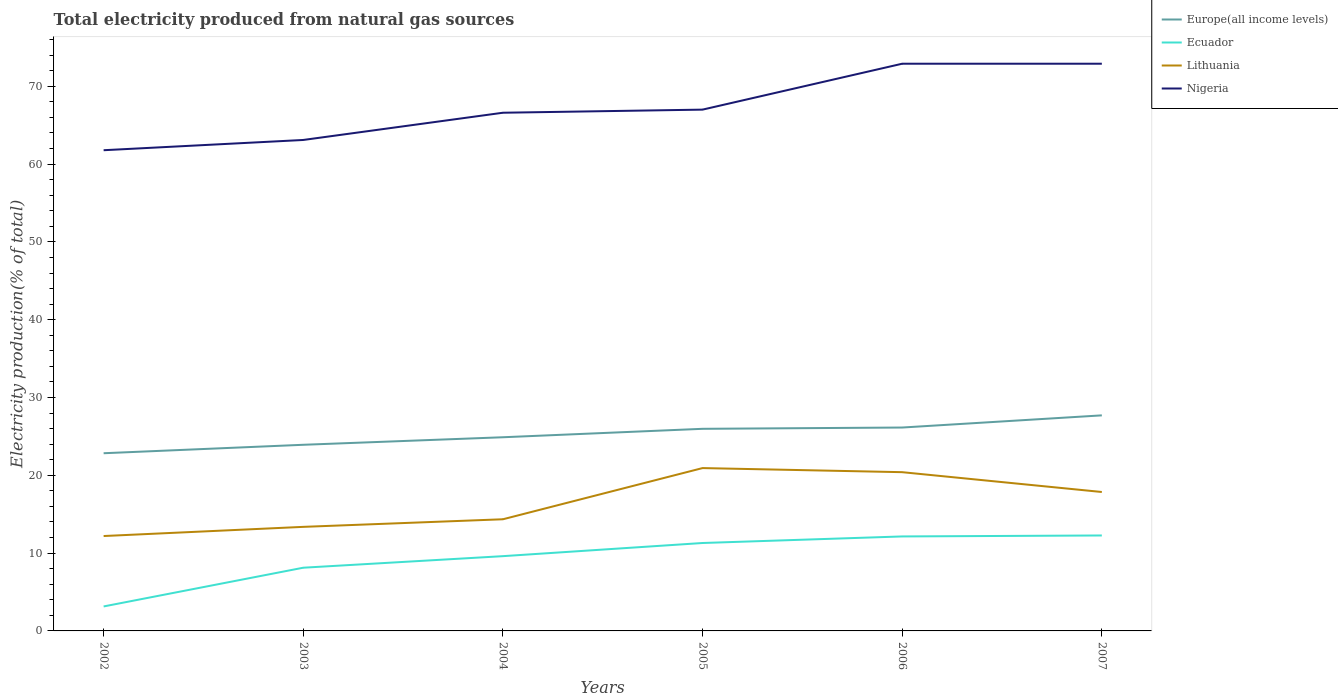How many different coloured lines are there?
Your response must be concise. 4. Does the line corresponding to Europe(all income levels) intersect with the line corresponding to Lithuania?
Your answer should be compact. No. Is the number of lines equal to the number of legend labels?
Provide a succinct answer. Yes. Across all years, what is the maximum total electricity produced in Lithuania?
Offer a very short reply. 12.19. What is the total total electricity produced in Europe(all income levels) in the graph?
Provide a short and direct response. -2.22. What is the difference between the highest and the second highest total electricity produced in Europe(all income levels)?
Provide a succinct answer. 4.87. Is the total electricity produced in Lithuania strictly greater than the total electricity produced in Ecuador over the years?
Ensure brevity in your answer.  No. How many lines are there?
Offer a terse response. 4. Does the graph contain any zero values?
Provide a short and direct response. No. Does the graph contain grids?
Give a very brief answer. No. Where does the legend appear in the graph?
Your response must be concise. Top right. How many legend labels are there?
Your response must be concise. 4. How are the legend labels stacked?
Offer a terse response. Vertical. What is the title of the graph?
Keep it short and to the point. Total electricity produced from natural gas sources. Does "Central Europe" appear as one of the legend labels in the graph?
Your answer should be compact. No. What is the Electricity production(% of total) of Europe(all income levels) in 2002?
Offer a very short reply. 22.84. What is the Electricity production(% of total) of Ecuador in 2002?
Ensure brevity in your answer.  3.15. What is the Electricity production(% of total) of Lithuania in 2002?
Provide a succinct answer. 12.19. What is the Electricity production(% of total) of Nigeria in 2002?
Your answer should be very brief. 61.78. What is the Electricity production(% of total) in Europe(all income levels) in 2003?
Your answer should be very brief. 23.92. What is the Electricity production(% of total) in Ecuador in 2003?
Offer a very short reply. 8.12. What is the Electricity production(% of total) of Lithuania in 2003?
Your answer should be very brief. 13.37. What is the Electricity production(% of total) in Nigeria in 2003?
Ensure brevity in your answer.  63.1. What is the Electricity production(% of total) of Europe(all income levels) in 2004?
Offer a very short reply. 24.89. What is the Electricity production(% of total) in Ecuador in 2004?
Make the answer very short. 9.61. What is the Electricity production(% of total) of Lithuania in 2004?
Your answer should be very brief. 14.35. What is the Electricity production(% of total) of Nigeria in 2004?
Your answer should be very brief. 66.6. What is the Electricity production(% of total) of Europe(all income levels) in 2005?
Your answer should be compact. 25.98. What is the Electricity production(% of total) of Ecuador in 2005?
Ensure brevity in your answer.  11.3. What is the Electricity production(% of total) of Lithuania in 2005?
Offer a terse response. 20.93. What is the Electricity production(% of total) in Nigeria in 2005?
Provide a succinct answer. 67. What is the Electricity production(% of total) of Europe(all income levels) in 2006?
Your answer should be very brief. 26.14. What is the Electricity production(% of total) in Ecuador in 2006?
Offer a very short reply. 12.14. What is the Electricity production(% of total) in Lithuania in 2006?
Keep it short and to the point. 20.4. What is the Electricity production(% of total) of Nigeria in 2006?
Provide a short and direct response. 72.9. What is the Electricity production(% of total) in Europe(all income levels) in 2007?
Your response must be concise. 27.71. What is the Electricity production(% of total) in Ecuador in 2007?
Your answer should be very brief. 12.27. What is the Electricity production(% of total) of Lithuania in 2007?
Offer a very short reply. 17.85. What is the Electricity production(% of total) in Nigeria in 2007?
Make the answer very short. 72.9. Across all years, what is the maximum Electricity production(% of total) of Europe(all income levels)?
Provide a short and direct response. 27.71. Across all years, what is the maximum Electricity production(% of total) in Ecuador?
Make the answer very short. 12.27. Across all years, what is the maximum Electricity production(% of total) of Lithuania?
Offer a very short reply. 20.93. Across all years, what is the maximum Electricity production(% of total) of Nigeria?
Offer a terse response. 72.9. Across all years, what is the minimum Electricity production(% of total) in Europe(all income levels)?
Ensure brevity in your answer.  22.84. Across all years, what is the minimum Electricity production(% of total) in Ecuador?
Keep it short and to the point. 3.15. Across all years, what is the minimum Electricity production(% of total) of Lithuania?
Provide a short and direct response. 12.19. Across all years, what is the minimum Electricity production(% of total) of Nigeria?
Offer a terse response. 61.78. What is the total Electricity production(% of total) of Europe(all income levels) in the graph?
Ensure brevity in your answer.  151.47. What is the total Electricity production(% of total) of Ecuador in the graph?
Offer a very short reply. 56.59. What is the total Electricity production(% of total) in Lithuania in the graph?
Offer a terse response. 99.11. What is the total Electricity production(% of total) in Nigeria in the graph?
Your answer should be compact. 404.28. What is the difference between the Electricity production(% of total) in Europe(all income levels) in 2002 and that in 2003?
Give a very brief answer. -1.09. What is the difference between the Electricity production(% of total) of Ecuador in 2002 and that in 2003?
Offer a terse response. -4.98. What is the difference between the Electricity production(% of total) in Lithuania in 2002 and that in 2003?
Give a very brief answer. -1.18. What is the difference between the Electricity production(% of total) in Nigeria in 2002 and that in 2003?
Offer a very short reply. -1.32. What is the difference between the Electricity production(% of total) in Europe(all income levels) in 2002 and that in 2004?
Your answer should be compact. -2.05. What is the difference between the Electricity production(% of total) of Ecuador in 2002 and that in 2004?
Ensure brevity in your answer.  -6.46. What is the difference between the Electricity production(% of total) of Lithuania in 2002 and that in 2004?
Offer a very short reply. -2.16. What is the difference between the Electricity production(% of total) of Nigeria in 2002 and that in 2004?
Offer a terse response. -4.82. What is the difference between the Electricity production(% of total) in Europe(all income levels) in 2002 and that in 2005?
Provide a succinct answer. -3.14. What is the difference between the Electricity production(% of total) in Ecuador in 2002 and that in 2005?
Give a very brief answer. -8.15. What is the difference between the Electricity production(% of total) in Lithuania in 2002 and that in 2005?
Your response must be concise. -8.73. What is the difference between the Electricity production(% of total) of Nigeria in 2002 and that in 2005?
Provide a short and direct response. -5.22. What is the difference between the Electricity production(% of total) of Europe(all income levels) in 2002 and that in 2006?
Your response must be concise. -3.3. What is the difference between the Electricity production(% of total) in Ecuador in 2002 and that in 2006?
Ensure brevity in your answer.  -9. What is the difference between the Electricity production(% of total) of Lithuania in 2002 and that in 2006?
Your answer should be very brief. -8.21. What is the difference between the Electricity production(% of total) in Nigeria in 2002 and that in 2006?
Offer a very short reply. -11.12. What is the difference between the Electricity production(% of total) of Europe(all income levels) in 2002 and that in 2007?
Your answer should be compact. -4.87. What is the difference between the Electricity production(% of total) in Ecuador in 2002 and that in 2007?
Your answer should be very brief. -9.12. What is the difference between the Electricity production(% of total) of Lithuania in 2002 and that in 2007?
Provide a succinct answer. -5.66. What is the difference between the Electricity production(% of total) of Nigeria in 2002 and that in 2007?
Your answer should be compact. -11.12. What is the difference between the Electricity production(% of total) of Europe(all income levels) in 2003 and that in 2004?
Ensure brevity in your answer.  -0.97. What is the difference between the Electricity production(% of total) in Ecuador in 2003 and that in 2004?
Give a very brief answer. -1.49. What is the difference between the Electricity production(% of total) of Lithuania in 2003 and that in 2004?
Keep it short and to the point. -0.98. What is the difference between the Electricity production(% of total) in Nigeria in 2003 and that in 2004?
Provide a succinct answer. -3.5. What is the difference between the Electricity production(% of total) of Europe(all income levels) in 2003 and that in 2005?
Your answer should be compact. -2.05. What is the difference between the Electricity production(% of total) of Ecuador in 2003 and that in 2005?
Your answer should be compact. -3.18. What is the difference between the Electricity production(% of total) of Lithuania in 2003 and that in 2005?
Ensure brevity in your answer.  -7.56. What is the difference between the Electricity production(% of total) of Europe(all income levels) in 2003 and that in 2006?
Keep it short and to the point. -2.22. What is the difference between the Electricity production(% of total) in Ecuador in 2003 and that in 2006?
Keep it short and to the point. -4.02. What is the difference between the Electricity production(% of total) in Lithuania in 2003 and that in 2006?
Provide a succinct answer. -7.03. What is the difference between the Electricity production(% of total) in Nigeria in 2003 and that in 2006?
Your answer should be very brief. -9.8. What is the difference between the Electricity production(% of total) of Europe(all income levels) in 2003 and that in 2007?
Offer a very short reply. -3.78. What is the difference between the Electricity production(% of total) in Ecuador in 2003 and that in 2007?
Provide a short and direct response. -4.14. What is the difference between the Electricity production(% of total) in Lithuania in 2003 and that in 2007?
Your answer should be very brief. -4.48. What is the difference between the Electricity production(% of total) in Nigeria in 2003 and that in 2007?
Your answer should be very brief. -9.8. What is the difference between the Electricity production(% of total) of Europe(all income levels) in 2004 and that in 2005?
Keep it short and to the point. -1.08. What is the difference between the Electricity production(% of total) of Ecuador in 2004 and that in 2005?
Offer a very short reply. -1.69. What is the difference between the Electricity production(% of total) in Lithuania in 2004 and that in 2005?
Make the answer very short. -6.58. What is the difference between the Electricity production(% of total) of Nigeria in 2004 and that in 2005?
Offer a very short reply. -0.4. What is the difference between the Electricity production(% of total) of Europe(all income levels) in 2004 and that in 2006?
Your response must be concise. -1.25. What is the difference between the Electricity production(% of total) in Ecuador in 2004 and that in 2006?
Offer a very short reply. -2.53. What is the difference between the Electricity production(% of total) of Lithuania in 2004 and that in 2006?
Offer a terse response. -6.05. What is the difference between the Electricity production(% of total) of Nigeria in 2004 and that in 2006?
Offer a very short reply. -6.3. What is the difference between the Electricity production(% of total) of Europe(all income levels) in 2004 and that in 2007?
Provide a short and direct response. -2.81. What is the difference between the Electricity production(% of total) in Ecuador in 2004 and that in 2007?
Offer a very short reply. -2.66. What is the difference between the Electricity production(% of total) in Lithuania in 2004 and that in 2007?
Give a very brief answer. -3.5. What is the difference between the Electricity production(% of total) of Nigeria in 2004 and that in 2007?
Offer a terse response. -6.3. What is the difference between the Electricity production(% of total) in Europe(all income levels) in 2005 and that in 2006?
Your answer should be very brief. -0.16. What is the difference between the Electricity production(% of total) of Ecuador in 2005 and that in 2006?
Offer a very short reply. -0.84. What is the difference between the Electricity production(% of total) of Lithuania in 2005 and that in 2006?
Make the answer very short. 0.53. What is the difference between the Electricity production(% of total) in Nigeria in 2005 and that in 2006?
Make the answer very short. -5.9. What is the difference between the Electricity production(% of total) of Europe(all income levels) in 2005 and that in 2007?
Offer a very short reply. -1.73. What is the difference between the Electricity production(% of total) in Ecuador in 2005 and that in 2007?
Offer a terse response. -0.97. What is the difference between the Electricity production(% of total) of Lithuania in 2005 and that in 2007?
Your answer should be very brief. 3.08. What is the difference between the Electricity production(% of total) in Nigeria in 2005 and that in 2007?
Offer a terse response. -5.9. What is the difference between the Electricity production(% of total) in Europe(all income levels) in 2006 and that in 2007?
Your answer should be compact. -1.57. What is the difference between the Electricity production(% of total) in Ecuador in 2006 and that in 2007?
Your answer should be very brief. -0.12. What is the difference between the Electricity production(% of total) in Lithuania in 2006 and that in 2007?
Keep it short and to the point. 2.55. What is the difference between the Electricity production(% of total) in Nigeria in 2006 and that in 2007?
Your answer should be very brief. -0. What is the difference between the Electricity production(% of total) in Europe(all income levels) in 2002 and the Electricity production(% of total) in Ecuador in 2003?
Make the answer very short. 14.71. What is the difference between the Electricity production(% of total) of Europe(all income levels) in 2002 and the Electricity production(% of total) of Lithuania in 2003?
Ensure brevity in your answer.  9.46. What is the difference between the Electricity production(% of total) in Europe(all income levels) in 2002 and the Electricity production(% of total) in Nigeria in 2003?
Give a very brief answer. -40.26. What is the difference between the Electricity production(% of total) in Ecuador in 2002 and the Electricity production(% of total) in Lithuania in 2003?
Make the answer very short. -10.23. What is the difference between the Electricity production(% of total) in Ecuador in 2002 and the Electricity production(% of total) in Nigeria in 2003?
Provide a short and direct response. -59.95. What is the difference between the Electricity production(% of total) of Lithuania in 2002 and the Electricity production(% of total) of Nigeria in 2003?
Offer a very short reply. -50.9. What is the difference between the Electricity production(% of total) in Europe(all income levels) in 2002 and the Electricity production(% of total) in Ecuador in 2004?
Offer a terse response. 13.23. What is the difference between the Electricity production(% of total) in Europe(all income levels) in 2002 and the Electricity production(% of total) in Lithuania in 2004?
Give a very brief answer. 8.49. What is the difference between the Electricity production(% of total) of Europe(all income levels) in 2002 and the Electricity production(% of total) of Nigeria in 2004?
Offer a terse response. -43.76. What is the difference between the Electricity production(% of total) in Ecuador in 2002 and the Electricity production(% of total) in Lithuania in 2004?
Your response must be concise. -11.2. What is the difference between the Electricity production(% of total) of Ecuador in 2002 and the Electricity production(% of total) of Nigeria in 2004?
Your response must be concise. -63.45. What is the difference between the Electricity production(% of total) of Lithuania in 2002 and the Electricity production(% of total) of Nigeria in 2004?
Your answer should be compact. -54.4. What is the difference between the Electricity production(% of total) of Europe(all income levels) in 2002 and the Electricity production(% of total) of Ecuador in 2005?
Provide a succinct answer. 11.54. What is the difference between the Electricity production(% of total) of Europe(all income levels) in 2002 and the Electricity production(% of total) of Lithuania in 2005?
Offer a terse response. 1.91. What is the difference between the Electricity production(% of total) of Europe(all income levels) in 2002 and the Electricity production(% of total) of Nigeria in 2005?
Your answer should be compact. -44.16. What is the difference between the Electricity production(% of total) in Ecuador in 2002 and the Electricity production(% of total) in Lithuania in 2005?
Offer a terse response. -17.78. What is the difference between the Electricity production(% of total) of Ecuador in 2002 and the Electricity production(% of total) of Nigeria in 2005?
Make the answer very short. -63.85. What is the difference between the Electricity production(% of total) in Lithuania in 2002 and the Electricity production(% of total) in Nigeria in 2005?
Your answer should be very brief. -54.8. What is the difference between the Electricity production(% of total) in Europe(all income levels) in 2002 and the Electricity production(% of total) in Ecuador in 2006?
Provide a short and direct response. 10.69. What is the difference between the Electricity production(% of total) in Europe(all income levels) in 2002 and the Electricity production(% of total) in Lithuania in 2006?
Your answer should be compact. 2.43. What is the difference between the Electricity production(% of total) of Europe(all income levels) in 2002 and the Electricity production(% of total) of Nigeria in 2006?
Give a very brief answer. -50.06. What is the difference between the Electricity production(% of total) of Ecuador in 2002 and the Electricity production(% of total) of Lithuania in 2006?
Provide a succinct answer. -17.26. What is the difference between the Electricity production(% of total) of Ecuador in 2002 and the Electricity production(% of total) of Nigeria in 2006?
Provide a succinct answer. -69.75. What is the difference between the Electricity production(% of total) of Lithuania in 2002 and the Electricity production(% of total) of Nigeria in 2006?
Give a very brief answer. -60.7. What is the difference between the Electricity production(% of total) in Europe(all income levels) in 2002 and the Electricity production(% of total) in Ecuador in 2007?
Offer a very short reply. 10.57. What is the difference between the Electricity production(% of total) in Europe(all income levels) in 2002 and the Electricity production(% of total) in Lithuania in 2007?
Provide a short and direct response. 4.98. What is the difference between the Electricity production(% of total) in Europe(all income levels) in 2002 and the Electricity production(% of total) in Nigeria in 2007?
Your answer should be very brief. -50.06. What is the difference between the Electricity production(% of total) in Ecuador in 2002 and the Electricity production(% of total) in Lithuania in 2007?
Ensure brevity in your answer.  -14.71. What is the difference between the Electricity production(% of total) of Ecuador in 2002 and the Electricity production(% of total) of Nigeria in 2007?
Provide a succinct answer. -69.75. What is the difference between the Electricity production(% of total) of Lithuania in 2002 and the Electricity production(% of total) of Nigeria in 2007?
Your response must be concise. -60.71. What is the difference between the Electricity production(% of total) in Europe(all income levels) in 2003 and the Electricity production(% of total) in Ecuador in 2004?
Your response must be concise. 14.32. What is the difference between the Electricity production(% of total) of Europe(all income levels) in 2003 and the Electricity production(% of total) of Lithuania in 2004?
Offer a terse response. 9.57. What is the difference between the Electricity production(% of total) in Europe(all income levels) in 2003 and the Electricity production(% of total) in Nigeria in 2004?
Offer a very short reply. -42.67. What is the difference between the Electricity production(% of total) of Ecuador in 2003 and the Electricity production(% of total) of Lithuania in 2004?
Your answer should be compact. -6.23. What is the difference between the Electricity production(% of total) of Ecuador in 2003 and the Electricity production(% of total) of Nigeria in 2004?
Your answer should be very brief. -58.48. What is the difference between the Electricity production(% of total) of Lithuania in 2003 and the Electricity production(% of total) of Nigeria in 2004?
Your answer should be compact. -53.23. What is the difference between the Electricity production(% of total) of Europe(all income levels) in 2003 and the Electricity production(% of total) of Ecuador in 2005?
Offer a terse response. 12.62. What is the difference between the Electricity production(% of total) in Europe(all income levels) in 2003 and the Electricity production(% of total) in Lithuania in 2005?
Your answer should be very brief. 2.99. What is the difference between the Electricity production(% of total) in Europe(all income levels) in 2003 and the Electricity production(% of total) in Nigeria in 2005?
Ensure brevity in your answer.  -43.08. What is the difference between the Electricity production(% of total) of Ecuador in 2003 and the Electricity production(% of total) of Lithuania in 2005?
Provide a succinct answer. -12.81. What is the difference between the Electricity production(% of total) in Ecuador in 2003 and the Electricity production(% of total) in Nigeria in 2005?
Your answer should be very brief. -58.88. What is the difference between the Electricity production(% of total) in Lithuania in 2003 and the Electricity production(% of total) in Nigeria in 2005?
Make the answer very short. -53.63. What is the difference between the Electricity production(% of total) in Europe(all income levels) in 2003 and the Electricity production(% of total) in Ecuador in 2006?
Your answer should be very brief. 11.78. What is the difference between the Electricity production(% of total) in Europe(all income levels) in 2003 and the Electricity production(% of total) in Lithuania in 2006?
Offer a terse response. 3.52. What is the difference between the Electricity production(% of total) in Europe(all income levels) in 2003 and the Electricity production(% of total) in Nigeria in 2006?
Your answer should be compact. -48.97. What is the difference between the Electricity production(% of total) of Ecuador in 2003 and the Electricity production(% of total) of Lithuania in 2006?
Offer a very short reply. -12.28. What is the difference between the Electricity production(% of total) in Ecuador in 2003 and the Electricity production(% of total) in Nigeria in 2006?
Provide a succinct answer. -64.78. What is the difference between the Electricity production(% of total) in Lithuania in 2003 and the Electricity production(% of total) in Nigeria in 2006?
Your response must be concise. -59.53. What is the difference between the Electricity production(% of total) in Europe(all income levels) in 2003 and the Electricity production(% of total) in Ecuador in 2007?
Offer a very short reply. 11.66. What is the difference between the Electricity production(% of total) in Europe(all income levels) in 2003 and the Electricity production(% of total) in Lithuania in 2007?
Provide a short and direct response. 6.07. What is the difference between the Electricity production(% of total) of Europe(all income levels) in 2003 and the Electricity production(% of total) of Nigeria in 2007?
Offer a very short reply. -48.98. What is the difference between the Electricity production(% of total) of Ecuador in 2003 and the Electricity production(% of total) of Lithuania in 2007?
Offer a very short reply. -9.73. What is the difference between the Electricity production(% of total) of Ecuador in 2003 and the Electricity production(% of total) of Nigeria in 2007?
Ensure brevity in your answer.  -64.78. What is the difference between the Electricity production(% of total) in Lithuania in 2003 and the Electricity production(% of total) in Nigeria in 2007?
Your response must be concise. -59.53. What is the difference between the Electricity production(% of total) of Europe(all income levels) in 2004 and the Electricity production(% of total) of Ecuador in 2005?
Offer a terse response. 13.59. What is the difference between the Electricity production(% of total) of Europe(all income levels) in 2004 and the Electricity production(% of total) of Lithuania in 2005?
Keep it short and to the point. 3.96. What is the difference between the Electricity production(% of total) in Europe(all income levels) in 2004 and the Electricity production(% of total) in Nigeria in 2005?
Provide a succinct answer. -42.11. What is the difference between the Electricity production(% of total) of Ecuador in 2004 and the Electricity production(% of total) of Lithuania in 2005?
Your response must be concise. -11.32. What is the difference between the Electricity production(% of total) of Ecuador in 2004 and the Electricity production(% of total) of Nigeria in 2005?
Give a very brief answer. -57.39. What is the difference between the Electricity production(% of total) of Lithuania in 2004 and the Electricity production(% of total) of Nigeria in 2005?
Your response must be concise. -52.65. What is the difference between the Electricity production(% of total) of Europe(all income levels) in 2004 and the Electricity production(% of total) of Ecuador in 2006?
Make the answer very short. 12.75. What is the difference between the Electricity production(% of total) in Europe(all income levels) in 2004 and the Electricity production(% of total) in Lithuania in 2006?
Your answer should be compact. 4.49. What is the difference between the Electricity production(% of total) in Europe(all income levels) in 2004 and the Electricity production(% of total) in Nigeria in 2006?
Your response must be concise. -48.01. What is the difference between the Electricity production(% of total) of Ecuador in 2004 and the Electricity production(% of total) of Lithuania in 2006?
Your answer should be compact. -10.79. What is the difference between the Electricity production(% of total) in Ecuador in 2004 and the Electricity production(% of total) in Nigeria in 2006?
Offer a very short reply. -63.29. What is the difference between the Electricity production(% of total) in Lithuania in 2004 and the Electricity production(% of total) in Nigeria in 2006?
Offer a terse response. -58.55. What is the difference between the Electricity production(% of total) in Europe(all income levels) in 2004 and the Electricity production(% of total) in Ecuador in 2007?
Your answer should be very brief. 12.62. What is the difference between the Electricity production(% of total) in Europe(all income levels) in 2004 and the Electricity production(% of total) in Lithuania in 2007?
Your answer should be very brief. 7.04. What is the difference between the Electricity production(% of total) of Europe(all income levels) in 2004 and the Electricity production(% of total) of Nigeria in 2007?
Keep it short and to the point. -48.01. What is the difference between the Electricity production(% of total) of Ecuador in 2004 and the Electricity production(% of total) of Lithuania in 2007?
Provide a short and direct response. -8.25. What is the difference between the Electricity production(% of total) of Ecuador in 2004 and the Electricity production(% of total) of Nigeria in 2007?
Keep it short and to the point. -63.29. What is the difference between the Electricity production(% of total) of Lithuania in 2004 and the Electricity production(% of total) of Nigeria in 2007?
Offer a very short reply. -58.55. What is the difference between the Electricity production(% of total) of Europe(all income levels) in 2005 and the Electricity production(% of total) of Ecuador in 2006?
Your answer should be compact. 13.83. What is the difference between the Electricity production(% of total) of Europe(all income levels) in 2005 and the Electricity production(% of total) of Lithuania in 2006?
Offer a very short reply. 5.57. What is the difference between the Electricity production(% of total) of Europe(all income levels) in 2005 and the Electricity production(% of total) of Nigeria in 2006?
Keep it short and to the point. -46.92. What is the difference between the Electricity production(% of total) of Ecuador in 2005 and the Electricity production(% of total) of Lithuania in 2006?
Give a very brief answer. -9.1. What is the difference between the Electricity production(% of total) of Ecuador in 2005 and the Electricity production(% of total) of Nigeria in 2006?
Ensure brevity in your answer.  -61.6. What is the difference between the Electricity production(% of total) in Lithuania in 2005 and the Electricity production(% of total) in Nigeria in 2006?
Provide a short and direct response. -51.97. What is the difference between the Electricity production(% of total) of Europe(all income levels) in 2005 and the Electricity production(% of total) of Ecuador in 2007?
Give a very brief answer. 13.71. What is the difference between the Electricity production(% of total) of Europe(all income levels) in 2005 and the Electricity production(% of total) of Lithuania in 2007?
Ensure brevity in your answer.  8.12. What is the difference between the Electricity production(% of total) in Europe(all income levels) in 2005 and the Electricity production(% of total) in Nigeria in 2007?
Provide a short and direct response. -46.92. What is the difference between the Electricity production(% of total) of Ecuador in 2005 and the Electricity production(% of total) of Lithuania in 2007?
Provide a succinct answer. -6.55. What is the difference between the Electricity production(% of total) of Ecuador in 2005 and the Electricity production(% of total) of Nigeria in 2007?
Your response must be concise. -61.6. What is the difference between the Electricity production(% of total) of Lithuania in 2005 and the Electricity production(% of total) of Nigeria in 2007?
Provide a short and direct response. -51.97. What is the difference between the Electricity production(% of total) in Europe(all income levels) in 2006 and the Electricity production(% of total) in Ecuador in 2007?
Offer a terse response. 13.87. What is the difference between the Electricity production(% of total) in Europe(all income levels) in 2006 and the Electricity production(% of total) in Lithuania in 2007?
Provide a short and direct response. 8.29. What is the difference between the Electricity production(% of total) of Europe(all income levels) in 2006 and the Electricity production(% of total) of Nigeria in 2007?
Ensure brevity in your answer.  -46.76. What is the difference between the Electricity production(% of total) in Ecuador in 2006 and the Electricity production(% of total) in Lithuania in 2007?
Your response must be concise. -5.71. What is the difference between the Electricity production(% of total) of Ecuador in 2006 and the Electricity production(% of total) of Nigeria in 2007?
Your answer should be very brief. -60.76. What is the difference between the Electricity production(% of total) in Lithuania in 2006 and the Electricity production(% of total) in Nigeria in 2007?
Your answer should be very brief. -52.5. What is the average Electricity production(% of total) of Europe(all income levels) per year?
Give a very brief answer. 25.25. What is the average Electricity production(% of total) in Ecuador per year?
Ensure brevity in your answer.  9.43. What is the average Electricity production(% of total) in Lithuania per year?
Ensure brevity in your answer.  16.52. What is the average Electricity production(% of total) in Nigeria per year?
Provide a short and direct response. 67.38. In the year 2002, what is the difference between the Electricity production(% of total) of Europe(all income levels) and Electricity production(% of total) of Ecuador?
Your response must be concise. 19.69. In the year 2002, what is the difference between the Electricity production(% of total) in Europe(all income levels) and Electricity production(% of total) in Lithuania?
Your response must be concise. 10.64. In the year 2002, what is the difference between the Electricity production(% of total) of Europe(all income levels) and Electricity production(% of total) of Nigeria?
Provide a succinct answer. -38.95. In the year 2002, what is the difference between the Electricity production(% of total) in Ecuador and Electricity production(% of total) in Lithuania?
Your answer should be very brief. -9.05. In the year 2002, what is the difference between the Electricity production(% of total) of Ecuador and Electricity production(% of total) of Nigeria?
Your answer should be compact. -58.64. In the year 2002, what is the difference between the Electricity production(% of total) of Lithuania and Electricity production(% of total) of Nigeria?
Provide a short and direct response. -49.59. In the year 2003, what is the difference between the Electricity production(% of total) in Europe(all income levels) and Electricity production(% of total) in Ecuador?
Provide a short and direct response. 15.8. In the year 2003, what is the difference between the Electricity production(% of total) of Europe(all income levels) and Electricity production(% of total) of Lithuania?
Offer a terse response. 10.55. In the year 2003, what is the difference between the Electricity production(% of total) in Europe(all income levels) and Electricity production(% of total) in Nigeria?
Ensure brevity in your answer.  -39.18. In the year 2003, what is the difference between the Electricity production(% of total) in Ecuador and Electricity production(% of total) in Lithuania?
Provide a short and direct response. -5.25. In the year 2003, what is the difference between the Electricity production(% of total) of Ecuador and Electricity production(% of total) of Nigeria?
Give a very brief answer. -54.98. In the year 2003, what is the difference between the Electricity production(% of total) of Lithuania and Electricity production(% of total) of Nigeria?
Provide a short and direct response. -49.73. In the year 2004, what is the difference between the Electricity production(% of total) of Europe(all income levels) and Electricity production(% of total) of Ecuador?
Provide a short and direct response. 15.28. In the year 2004, what is the difference between the Electricity production(% of total) of Europe(all income levels) and Electricity production(% of total) of Lithuania?
Offer a terse response. 10.54. In the year 2004, what is the difference between the Electricity production(% of total) in Europe(all income levels) and Electricity production(% of total) in Nigeria?
Your response must be concise. -41.71. In the year 2004, what is the difference between the Electricity production(% of total) of Ecuador and Electricity production(% of total) of Lithuania?
Offer a very short reply. -4.74. In the year 2004, what is the difference between the Electricity production(% of total) of Ecuador and Electricity production(% of total) of Nigeria?
Ensure brevity in your answer.  -56.99. In the year 2004, what is the difference between the Electricity production(% of total) of Lithuania and Electricity production(% of total) of Nigeria?
Offer a very short reply. -52.25. In the year 2005, what is the difference between the Electricity production(% of total) in Europe(all income levels) and Electricity production(% of total) in Ecuador?
Offer a very short reply. 14.68. In the year 2005, what is the difference between the Electricity production(% of total) in Europe(all income levels) and Electricity production(% of total) in Lithuania?
Make the answer very short. 5.05. In the year 2005, what is the difference between the Electricity production(% of total) of Europe(all income levels) and Electricity production(% of total) of Nigeria?
Ensure brevity in your answer.  -41.02. In the year 2005, what is the difference between the Electricity production(% of total) of Ecuador and Electricity production(% of total) of Lithuania?
Make the answer very short. -9.63. In the year 2005, what is the difference between the Electricity production(% of total) of Ecuador and Electricity production(% of total) of Nigeria?
Give a very brief answer. -55.7. In the year 2005, what is the difference between the Electricity production(% of total) of Lithuania and Electricity production(% of total) of Nigeria?
Your answer should be very brief. -46.07. In the year 2006, what is the difference between the Electricity production(% of total) in Europe(all income levels) and Electricity production(% of total) in Ecuador?
Offer a terse response. 14. In the year 2006, what is the difference between the Electricity production(% of total) in Europe(all income levels) and Electricity production(% of total) in Lithuania?
Your answer should be compact. 5.74. In the year 2006, what is the difference between the Electricity production(% of total) in Europe(all income levels) and Electricity production(% of total) in Nigeria?
Make the answer very short. -46.76. In the year 2006, what is the difference between the Electricity production(% of total) in Ecuador and Electricity production(% of total) in Lithuania?
Offer a very short reply. -8.26. In the year 2006, what is the difference between the Electricity production(% of total) of Ecuador and Electricity production(% of total) of Nigeria?
Provide a short and direct response. -60.76. In the year 2006, what is the difference between the Electricity production(% of total) in Lithuania and Electricity production(% of total) in Nigeria?
Make the answer very short. -52.5. In the year 2007, what is the difference between the Electricity production(% of total) in Europe(all income levels) and Electricity production(% of total) in Ecuador?
Provide a short and direct response. 15.44. In the year 2007, what is the difference between the Electricity production(% of total) in Europe(all income levels) and Electricity production(% of total) in Lithuania?
Ensure brevity in your answer.  9.85. In the year 2007, what is the difference between the Electricity production(% of total) in Europe(all income levels) and Electricity production(% of total) in Nigeria?
Ensure brevity in your answer.  -45.19. In the year 2007, what is the difference between the Electricity production(% of total) in Ecuador and Electricity production(% of total) in Lithuania?
Provide a succinct answer. -5.59. In the year 2007, what is the difference between the Electricity production(% of total) of Ecuador and Electricity production(% of total) of Nigeria?
Your answer should be compact. -60.63. In the year 2007, what is the difference between the Electricity production(% of total) of Lithuania and Electricity production(% of total) of Nigeria?
Offer a very short reply. -55.05. What is the ratio of the Electricity production(% of total) of Europe(all income levels) in 2002 to that in 2003?
Your answer should be very brief. 0.95. What is the ratio of the Electricity production(% of total) of Ecuador in 2002 to that in 2003?
Give a very brief answer. 0.39. What is the ratio of the Electricity production(% of total) of Lithuania in 2002 to that in 2003?
Keep it short and to the point. 0.91. What is the ratio of the Electricity production(% of total) in Nigeria in 2002 to that in 2003?
Your response must be concise. 0.98. What is the ratio of the Electricity production(% of total) of Europe(all income levels) in 2002 to that in 2004?
Give a very brief answer. 0.92. What is the ratio of the Electricity production(% of total) of Ecuador in 2002 to that in 2004?
Provide a short and direct response. 0.33. What is the ratio of the Electricity production(% of total) of Lithuania in 2002 to that in 2004?
Your response must be concise. 0.85. What is the ratio of the Electricity production(% of total) of Nigeria in 2002 to that in 2004?
Provide a short and direct response. 0.93. What is the ratio of the Electricity production(% of total) of Europe(all income levels) in 2002 to that in 2005?
Ensure brevity in your answer.  0.88. What is the ratio of the Electricity production(% of total) of Ecuador in 2002 to that in 2005?
Ensure brevity in your answer.  0.28. What is the ratio of the Electricity production(% of total) in Lithuania in 2002 to that in 2005?
Offer a terse response. 0.58. What is the ratio of the Electricity production(% of total) of Nigeria in 2002 to that in 2005?
Offer a terse response. 0.92. What is the ratio of the Electricity production(% of total) in Europe(all income levels) in 2002 to that in 2006?
Keep it short and to the point. 0.87. What is the ratio of the Electricity production(% of total) of Ecuador in 2002 to that in 2006?
Give a very brief answer. 0.26. What is the ratio of the Electricity production(% of total) in Lithuania in 2002 to that in 2006?
Keep it short and to the point. 0.6. What is the ratio of the Electricity production(% of total) in Nigeria in 2002 to that in 2006?
Make the answer very short. 0.85. What is the ratio of the Electricity production(% of total) in Europe(all income levels) in 2002 to that in 2007?
Your answer should be compact. 0.82. What is the ratio of the Electricity production(% of total) of Ecuador in 2002 to that in 2007?
Your answer should be compact. 0.26. What is the ratio of the Electricity production(% of total) of Lithuania in 2002 to that in 2007?
Provide a short and direct response. 0.68. What is the ratio of the Electricity production(% of total) in Nigeria in 2002 to that in 2007?
Make the answer very short. 0.85. What is the ratio of the Electricity production(% of total) of Europe(all income levels) in 2003 to that in 2004?
Offer a terse response. 0.96. What is the ratio of the Electricity production(% of total) of Ecuador in 2003 to that in 2004?
Ensure brevity in your answer.  0.85. What is the ratio of the Electricity production(% of total) in Lithuania in 2003 to that in 2004?
Your answer should be very brief. 0.93. What is the ratio of the Electricity production(% of total) in Nigeria in 2003 to that in 2004?
Your response must be concise. 0.95. What is the ratio of the Electricity production(% of total) of Europe(all income levels) in 2003 to that in 2005?
Offer a terse response. 0.92. What is the ratio of the Electricity production(% of total) of Ecuador in 2003 to that in 2005?
Offer a very short reply. 0.72. What is the ratio of the Electricity production(% of total) in Lithuania in 2003 to that in 2005?
Your answer should be compact. 0.64. What is the ratio of the Electricity production(% of total) of Nigeria in 2003 to that in 2005?
Your answer should be very brief. 0.94. What is the ratio of the Electricity production(% of total) of Europe(all income levels) in 2003 to that in 2006?
Make the answer very short. 0.92. What is the ratio of the Electricity production(% of total) in Ecuador in 2003 to that in 2006?
Your answer should be compact. 0.67. What is the ratio of the Electricity production(% of total) of Lithuania in 2003 to that in 2006?
Your response must be concise. 0.66. What is the ratio of the Electricity production(% of total) in Nigeria in 2003 to that in 2006?
Your answer should be very brief. 0.87. What is the ratio of the Electricity production(% of total) in Europe(all income levels) in 2003 to that in 2007?
Provide a succinct answer. 0.86. What is the ratio of the Electricity production(% of total) of Ecuador in 2003 to that in 2007?
Give a very brief answer. 0.66. What is the ratio of the Electricity production(% of total) in Lithuania in 2003 to that in 2007?
Your answer should be very brief. 0.75. What is the ratio of the Electricity production(% of total) in Nigeria in 2003 to that in 2007?
Provide a succinct answer. 0.87. What is the ratio of the Electricity production(% of total) of Ecuador in 2004 to that in 2005?
Provide a short and direct response. 0.85. What is the ratio of the Electricity production(% of total) in Lithuania in 2004 to that in 2005?
Your response must be concise. 0.69. What is the ratio of the Electricity production(% of total) in Nigeria in 2004 to that in 2005?
Provide a short and direct response. 0.99. What is the ratio of the Electricity production(% of total) in Europe(all income levels) in 2004 to that in 2006?
Offer a terse response. 0.95. What is the ratio of the Electricity production(% of total) in Ecuador in 2004 to that in 2006?
Your response must be concise. 0.79. What is the ratio of the Electricity production(% of total) in Lithuania in 2004 to that in 2006?
Provide a short and direct response. 0.7. What is the ratio of the Electricity production(% of total) of Nigeria in 2004 to that in 2006?
Make the answer very short. 0.91. What is the ratio of the Electricity production(% of total) of Europe(all income levels) in 2004 to that in 2007?
Your answer should be compact. 0.9. What is the ratio of the Electricity production(% of total) in Ecuador in 2004 to that in 2007?
Provide a short and direct response. 0.78. What is the ratio of the Electricity production(% of total) in Lithuania in 2004 to that in 2007?
Your answer should be very brief. 0.8. What is the ratio of the Electricity production(% of total) in Nigeria in 2004 to that in 2007?
Provide a succinct answer. 0.91. What is the ratio of the Electricity production(% of total) in Ecuador in 2005 to that in 2006?
Make the answer very short. 0.93. What is the ratio of the Electricity production(% of total) of Lithuania in 2005 to that in 2006?
Your answer should be compact. 1.03. What is the ratio of the Electricity production(% of total) in Nigeria in 2005 to that in 2006?
Keep it short and to the point. 0.92. What is the ratio of the Electricity production(% of total) of Europe(all income levels) in 2005 to that in 2007?
Ensure brevity in your answer.  0.94. What is the ratio of the Electricity production(% of total) in Ecuador in 2005 to that in 2007?
Your response must be concise. 0.92. What is the ratio of the Electricity production(% of total) of Lithuania in 2005 to that in 2007?
Make the answer very short. 1.17. What is the ratio of the Electricity production(% of total) of Nigeria in 2005 to that in 2007?
Give a very brief answer. 0.92. What is the ratio of the Electricity production(% of total) of Europe(all income levels) in 2006 to that in 2007?
Provide a short and direct response. 0.94. What is the ratio of the Electricity production(% of total) in Lithuania in 2006 to that in 2007?
Offer a terse response. 1.14. What is the difference between the highest and the second highest Electricity production(% of total) in Europe(all income levels)?
Ensure brevity in your answer.  1.57. What is the difference between the highest and the second highest Electricity production(% of total) of Ecuador?
Give a very brief answer. 0.12. What is the difference between the highest and the second highest Electricity production(% of total) in Lithuania?
Offer a terse response. 0.53. What is the difference between the highest and the lowest Electricity production(% of total) in Europe(all income levels)?
Make the answer very short. 4.87. What is the difference between the highest and the lowest Electricity production(% of total) of Ecuador?
Offer a very short reply. 9.12. What is the difference between the highest and the lowest Electricity production(% of total) in Lithuania?
Provide a succinct answer. 8.73. What is the difference between the highest and the lowest Electricity production(% of total) of Nigeria?
Make the answer very short. 11.12. 